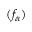<formula> <loc_0><loc_0><loc_500><loc_500>( f _ { \alpha } )</formula> 